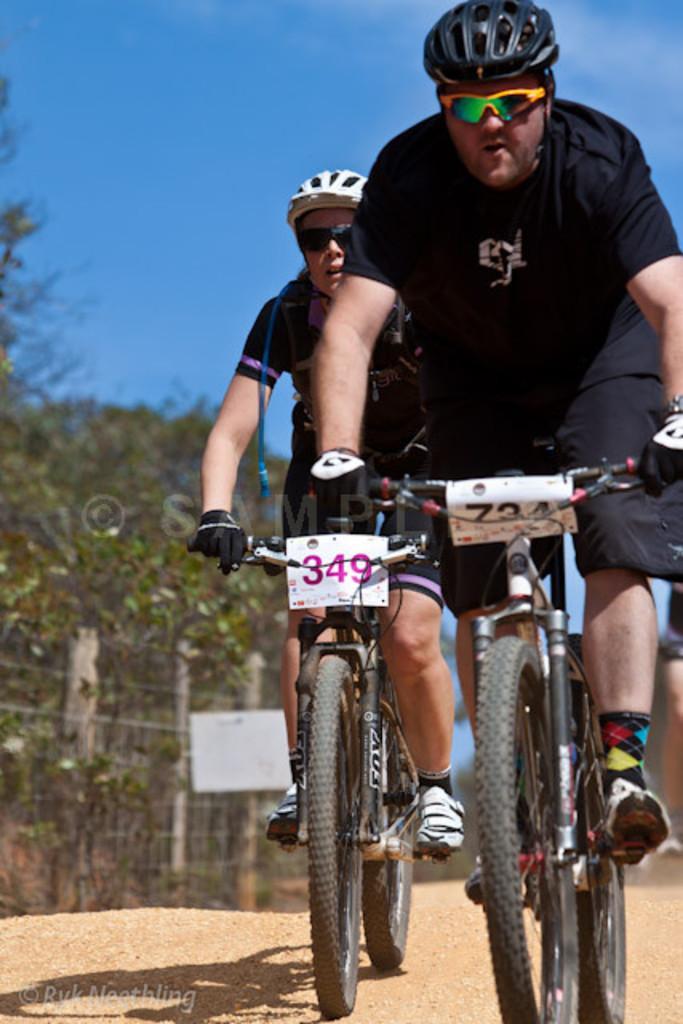How would you summarize this image in a sentence or two? There are two people sitting and riding bicycle and wore helmets and glasses and we can see stickers on these two bicycles. In the background we can see trees,fence and sky in blue color. 